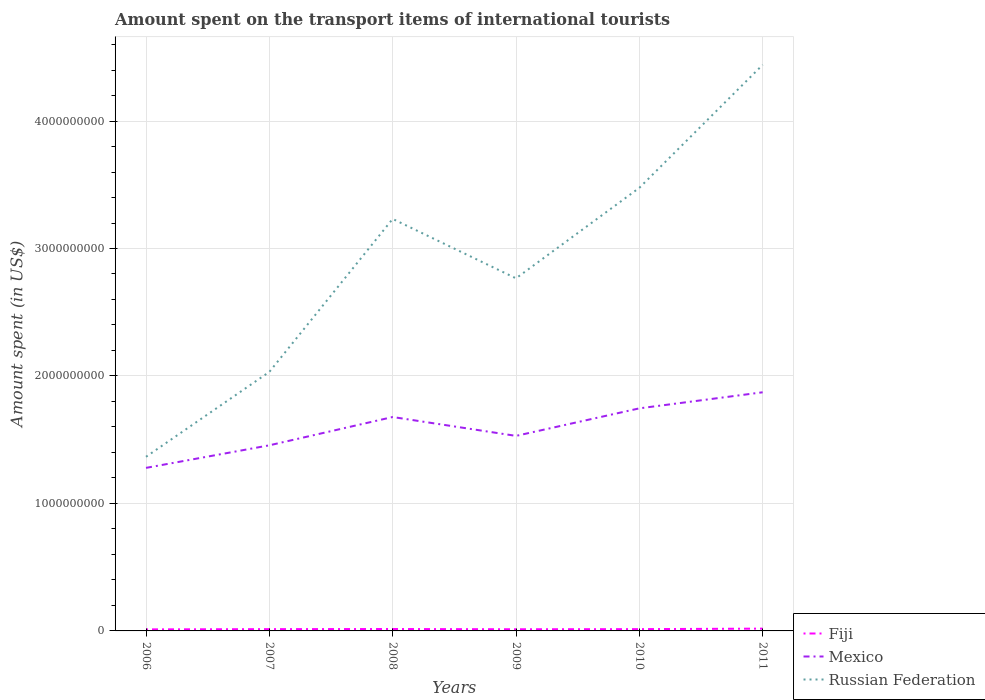How many different coloured lines are there?
Provide a short and direct response. 3. Is the number of lines equal to the number of legend labels?
Provide a short and direct response. Yes. Across all years, what is the maximum amount spent on the transport items of international tourists in Russian Federation?
Your answer should be compact. 1.37e+09. What is the total amount spent on the transport items of international tourists in Fiji in the graph?
Offer a terse response. -4.00e+06. What is the difference between the highest and the second highest amount spent on the transport items of international tourists in Russian Federation?
Provide a short and direct response. 3.08e+09. What is the difference between the highest and the lowest amount spent on the transport items of international tourists in Russian Federation?
Offer a terse response. 3. Is the amount spent on the transport items of international tourists in Mexico strictly greater than the amount spent on the transport items of international tourists in Fiji over the years?
Your answer should be very brief. No. What is the difference between two consecutive major ticks on the Y-axis?
Give a very brief answer. 1.00e+09. Does the graph contain any zero values?
Ensure brevity in your answer.  No. How many legend labels are there?
Provide a short and direct response. 3. How are the legend labels stacked?
Ensure brevity in your answer.  Vertical. What is the title of the graph?
Give a very brief answer. Amount spent on the transport items of international tourists. What is the label or title of the X-axis?
Make the answer very short. Years. What is the label or title of the Y-axis?
Your answer should be compact. Amount spent (in US$). What is the Amount spent (in US$) in Mexico in 2006?
Give a very brief answer. 1.28e+09. What is the Amount spent (in US$) in Russian Federation in 2006?
Provide a succinct answer. 1.37e+09. What is the Amount spent (in US$) in Fiji in 2007?
Your response must be concise. 1.40e+07. What is the Amount spent (in US$) of Mexico in 2007?
Give a very brief answer. 1.46e+09. What is the Amount spent (in US$) in Russian Federation in 2007?
Keep it short and to the point. 2.03e+09. What is the Amount spent (in US$) of Fiji in 2008?
Offer a terse response. 1.50e+07. What is the Amount spent (in US$) in Mexico in 2008?
Provide a short and direct response. 1.68e+09. What is the Amount spent (in US$) of Russian Federation in 2008?
Provide a succinct answer. 3.23e+09. What is the Amount spent (in US$) in Fiji in 2009?
Offer a very short reply. 1.30e+07. What is the Amount spent (in US$) of Mexico in 2009?
Provide a short and direct response. 1.53e+09. What is the Amount spent (in US$) of Russian Federation in 2009?
Keep it short and to the point. 2.77e+09. What is the Amount spent (in US$) in Fiji in 2010?
Provide a succinct answer. 1.40e+07. What is the Amount spent (in US$) in Mexico in 2010?
Offer a very short reply. 1.75e+09. What is the Amount spent (in US$) in Russian Federation in 2010?
Give a very brief answer. 3.48e+09. What is the Amount spent (in US$) of Fiji in 2011?
Make the answer very short. 1.80e+07. What is the Amount spent (in US$) in Mexico in 2011?
Ensure brevity in your answer.  1.87e+09. What is the Amount spent (in US$) of Russian Federation in 2011?
Offer a terse response. 4.44e+09. Across all years, what is the maximum Amount spent (in US$) of Fiji?
Make the answer very short. 1.80e+07. Across all years, what is the maximum Amount spent (in US$) of Mexico?
Provide a short and direct response. 1.87e+09. Across all years, what is the maximum Amount spent (in US$) of Russian Federation?
Provide a succinct answer. 4.44e+09. Across all years, what is the minimum Amount spent (in US$) of Fiji?
Your answer should be compact. 1.20e+07. Across all years, what is the minimum Amount spent (in US$) of Mexico?
Provide a succinct answer. 1.28e+09. Across all years, what is the minimum Amount spent (in US$) of Russian Federation?
Your answer should be compact. 1.37e+09. What is the total Amount spent (in US$) of Fiji in the graph?
Your answer should be very brief. 8.60e+07. What is the total Amount spent (in US$) of Mexico in the graph?
Provide a short and direct response. 9.56e+09. What is the total Amount spent (in US$) in Russian Federation in the graph?
Offer a terse response. 1.73e+1. What is the difference between the Amount spent (in US$) of Mexico in 2006 and that in 2007?
Provide a short and direct response. -1.77e+08. What is the difference between the Amount spent (in US$) of Russian Federation in 2006 and that in 2007?
Give a very brief answer. -6.66e+08. What is the difference between the Amount spent (in US$) in Fiji in 2006 and that in 2008?
Offer a very short reply. -3.00e+06. What is the difference between the Amount spent (in US$) of Mexico in 2006 and that in 2008?
Give a very brief answer. -3.99e+08. What is the difference between the Amount spent (in US$) of Russian Federation in 2006 and that in 2008?
Provide a succinct answer. -1.87e+09. What is the difference between the Amount spent (in US$) in Fiji in 2006 and that in 2009?
Give a very brief answer. -1.00e+06. What is the difference between the Amount spent (in US$) in Mexico in 2006 and that in 2009?
Your response must be concise. -2.51e+08. What is the difference between the Amount spent (in US$) of Russian Federation in 2006 and that in 2009?
Ensure brevity in your answer.  -1.40e+09. What is the difference between the Amount spent (in US$) of Mexico in 2006 and that in 2010?
Provide a succinct answer. -4.67e+08. What is the difference between the Amount spent (in US$) of Russian Federation in 2006 and that in 2010?
Make the answer very short. -2.11e+09. What is the difference between the Amount spent (in US$) in Fiji in 2006 and that in 2011?
Make the answer very short. -6.00e+06. What is the difference between the Amount spent (in US$) in Mexico in 2006 and that in 2011?
Offer a terse response. -5.93e+08. What is the difference between the Amount spent (in US$) of Russian Federation in 2006 and that in 2011?
Offer a terse response. -3.08e+09. What is the difference between the Amount spent (in US$) in Mexico in 2007 and that in 2008?
Your answer should be compact. -2.22e+08. What is the difference between the Amount spent (in US$) of Russian Federation in 2007 and that in 2008?
Keep it short and to the point. -1.20e+09. What is the difference between the Amount spent (in US$) of Fiji in 2007 and that in 2009?
Give a very brief answer. 1.00e+06. What is the difference between the Amount spent (in US$) of Mexico in 2007 and that in 2009?
Provide a short and direct response. -7.40e+07. What is the difference between the Amount spent (in US$) of Russian Federation in 2007 and that in 2009?
Provide a succinct answer. -7.34e+08. What is the difference between the Amount spent (in US$) in Mexico in 2007 and that in 2010?
Provide a succinct answer. -2.90e+08. What is the difference between the Amount spent (in US$) of Russian Federation in 2007 and that in 2010?
Your response must be concise. -1.44e+09. What is the difference between the Amount spent (in US$) of Fiji in 2007 and that in 2011?
Ensure brevity in your answer.  -4.00e+06. What is the difference between the Amount spent (in US$) of Mexico in 2007 and that in 2011?
Offer a very short reply. -4.16e+08. What is the difference between the Amount spent (in US$) in Russian Federation in 2007 and that in 2011?
Provide a short and direct response. -2.41e+09. What is the difference between the Amount spent (in US$) in Mexico in 2008 and that in 2009?
Your answer should be very brief. 1.48e+08. What is the difference between the Amount spent (in US$) in Russian Federation in 2008 and that in 2009?
Offer a very short reply. 4.66e+08. What is the difference between the Amount spent (in US$) in Mexico in 2008 and that in 2010?
Your response must be concise. -6.80e+07. What is the difference between the Amount spent (in US$) in Russian Federation in 2008 and that in 2010?
Your answer should be compact. -2.44e+08. What is the difference between the Amount spent (in US$) of Mexico in 2008 and that in 2011?
Your answer should be compact. -1.94e+08. What is the difference between the Amount spent (in US$) of Russian Federation in 2008 and that in 2011?
Your response must be concise. -1.21e+09. What is the difference between the Amount spent (in US$) of Fiji in 2009 and that in 2010?
Give a very brief answer. -1.00e+06. What is the difference between the Amount spent (in US$) of Mexico in 2009 and that in 2010?
Give a very brief answer. -2.16e+08. What is the difference between the Amount spent (in US$) in Russian Federation in 2009 and that in 2010?
Your answer should be very brief. -7.10e+08. What is the difference between the Amount spent (in US$) in Fiji in 2009 and that in 2011?
Provide a short and direct response. -5.00e+06. What is the difference between the Amount spent (in US$) in Mexico in 2009 and that in 2011?
Keep it short and to the point. -3.42e+08. What is the difference between the Amount spent (in US$) of Russian Federation in 2009 and that in 2011?
Offer a very short reply. -1.68e+09. What is the difference between the Amount spent (in US$) in Mexico in 2010 and that in 2011?
Make the answer very short. -1.26e+08. What is the difference between the Amount spent (in US$) of Russian Federation in 2010 and that in 2011?
Your response must be concise. -9.65e+08. What is the difference between the Amount spent (in US$) in Fiji in 2006 and the Amount spent (in US$) in Mexico in 2007?
Your answer should be compact. -1.44e+09. What is the difference between the Amount spent (in US$) in Fiji in 2006 and the Amount spent (in US$) in Russian Federation in 2007?
Your response must be concise. -2.02e+09. What is the difference between the Amount spent (in US$) in Mexico in 2006 and the Amount spent (in US$) in Russian Federation in 2007?
Offer a very short reply. -7.53e+08. What is the difference between the Amount spent (in US$) of Fiji in 2006 and the Amount spent (in US$) of Mexico in 2008?
Give a very brief answer. -1.67e+09. What is the difference between the Amount spent (in US$) of Fiji in 2006 and the Amount spent (in US$) of Russian Federation in 2008?
Ensure brevity in your answer.  -3.22e+09. What is the difference between the Amount spent (in US$) of Mexico in 2006 and the Amount spent (in US$) of Russian Federation in 2008?
Offer a very short reply. -1.95e+09. What is the difference between the Amount spent (in US$) in Fiji in 2006 and the Amount spent (in US$) in Mexico in 2009?
Your response must be concise. -1.52e+09. What is the difference between the Amount spent (in US$) in Fiji in 2006 and the Amount spent (in US$) in Russian Federation in 2009?
Make the answer very short. -2.75e+09. What is the difference between the Amount spent (in US$) in Mexico in 2006 and the Amount spent (in US$) in Russian Federation in 2009?
Offer a terse response. -1.49e+09. What is the difference between the Amount spent (in US$) in Fiji in 2006 and the Amount spent (in US$) in Mexico in 2010?
Offer a very short reply. -1.73e+09. What is the difference between the Amount spent (in US$) of Fiji in 2006 and the Amount spent (in US$) of Russian Federation in 2010?
Your answer should be very brief. -3.46e+09. What is the difference between the Amount spent (in US$) of Mexico in 2006 and the Amount spent (in US$) of Russian Federation in 2010?
Provide a succinct answer. -2.20e+09. What is the difference between the Amount spent (in US$) of Fiji in 2006 and the Amount spent (in US$) of Mexico in 2011?
Make the answer very short. -1.86e+09. What is the difference between the Amount spent (in US$) of Fiji in 2006 and the Amount spent (in US$) of Russian Federation in 2011?
Provide a succinct answer. -4.43e+09. What is the difference between the Amount spent (in US$) in Mexico in 2006 and the Amount spent (in US$) in Russian Federation in 2011?
Your response must be concise. -3.16e+09. What is the difference between the Amount spent (in US$) of Fiji in 2007 and the Amount spent (in US$) of Mexico in 2008?
Give a very brief answer. -1.66e+09. What is the difference between the Amount spent (in US$) in Fiji in 2007 and the Amount spent (in US$) in Russian Federation in 2008?
Make the answer very short. -3.22e+09. What is the difference between the Amount spent (in US$) in Mexico in 2007 and the Amount spent (in US$) in Russian Federation in 2008?
Keep it short and to the point. -1.78e+09. What is the difference between the Amount spent (in US$) in Fiji in 2007 and the Amount spent (in US$) in Mexico in 2009?
Your answer should be compact. -1.52e+09. What is the difference between the Amount spent (in US$) of Fiji in 2007 and the Amount spent (in US$) of Russian Federation in 2009?
Ensure brevity in your answer.  -2.75e+09. What is the difference between the Amount spent (in US$) of Mexico in 2007 and the Amount spent (in US$) of Russian Federation in 2009?
Keep it short and to the point. -1.31e+09. What is the difference between the Amount spent (in US$) of Fiji in 2007 and the Amount spent (in US$) of Mexico in 2010?
Offer a very short reply. -1.73e+09. What is the difference between the Amount spent (in US$) of Fiji in 2007 and the Amount spent (in US$) of Russian Federation in 2010?
Your response must be concise. -3.46e+09. What is the difference between the Amount spent (in US$) of Mexico in 2007 and the Amount spent (in US$) of Russian Federation in 2010?
Offer a very short reply. -2.02e+09. What is the difference between the Amount spent (in US$) in Fiji in 2007 and the Amount spent (in US$) in Mexico in 2011?
Provide a succinct answer. -1.86e+09. What is the difference between the Amount spent (in US$) of Fiji in 2007 and the Amount spent (in US$) of Russian Federation in 2011?
Make the answer very short. -4.43e+09. What is the difference between the Amount spent (in US$) in Mexico in 2007 and the Amount spent (in US$) in Russian Federation in 2011?
Your response must be concise. -2.98e+09. What is the difference between the Amount spent (in US$) in Fiji in 2008 and the Amount spent (in US$) in Mexico in 2009?
Keep it short and to the point. -1.52e+09. What is the difference between the Amount spent (in US$) of Fiji in 2008 and the Amount spent (in US$) of Russian Federation in 2009?
Give a very brief answer. -2.75e+09. What is the difference between the Amount spent (in US$) of Mexico in 2008 and the Amount spent (in US$) of Russian Federation in 2009?
Offer a terse response. -1.09e+09. What is the difference between the Amount spent (in US$) in Fiji in 2008 and the Amount spent (in US$) in Mexico in 2010?
Provide a succinct answer. -1.73e+09. What is the difference between the Amount spent (in US$) in Fiji in 2008 and the Amount spent (in US$) in Russian Federation in 2010?
Keep it short and to the point. -3.46e+09. What is the difference between the Amount spent (in US$) in Mexico in 2008 and the Amount spent (in US$) in Russian Federation in 2010?
Offer a very short reply. -1.80e+09. What is the difference between the Amount spent (in US$) in Fiji in 2008 and the Amount spent (in US$) in Mexico in 2011?
Offer a very short reply. -1.86e+09. What is the difference between the Amount spent (in US$) of Fiji in 2008 and the Amount spent (in US$) of Russian Federation in 2011?
Offer a terse response. -4.43e+09. What is the difference between the Amount spent (in US$) in Mexico in 2008 and the Amount spent (in US$) in Russian Federation in 2011?
Make the answer very short. -2.76e+09. What is the difference between the Amount spent (in US$) in Fiji in 2009 and the Amount spent (in US$) in Mexico in 2010?
Give a very brief answer. -1.73e+09. What is the difference between the Amount spent (in US$) of Fiji in 2009 and the Amount spent (in US$) of Russian Federation in 2010?
Your answer should be compact. -3.46e+09. What is the difference between the Amount spent (in US$) in Mexico in 2009 and the Amount spent (in US$) in Russian Federation in 2010?
Your response must be concise. -1.95e+09. What is the difference between the Amount spent (in US$) of Fiji in 2009 and the Amount spent (in US$) of Mexico in 2011?
Provide a short and direct response. -1.86e+09. What is the difference between the Amount spent (in US$) in Fiji in 2009 and the Amount spent (in US$) in Russian Federation in 2011?
Ensure brevity in your answer.  -4.43e+09. What is the difference between the Amount spent (in US$) of Mexico in 2009 and the Amount spent (in US$) of Russian Federation in 2011?
Provide a succinct answer. -2.91e+09. What is the difference between the Amount spent (in US$) in Fiji in 2010 and the Amount spent (in US$) in Mexico in 2011?
Offer a terse response. -1.86e+09. What is the difference between the Amount spent (in US$) in Fiji in 2010 and the Amount spent (in US$) in Russian Federation in 2011?
Give a very brief answer. -4.43e+09. What is the difference between the Amount spent (in US$) of Mexico in 2010 and the Amount spent (in US$) of Russian Federation in 2011?
Give a very brief answer. -2.70e+09. What is the average Amount spent (in US$) in Fiji per year?
Give a very brief answer. 1.43e+07. What is the average Amount spent (in US$) of Mexico per year?
Offer a terse response. 1.59e+09. What is the average Amount spent (in US$) of Russian Federation per year?
Give a very brief answer. 2.89e+09. In the year 2006, what is the difference between the Amount spent (in US$) in Fiji and Amount spent (in US$) in Mexico?
Ensure brevity in your answer.  -1.27e+09. In the year 2006, what is the difference between the Amount spent (in US$) in Fiji and Amount spent (in US$) in Russian Federation?
Your answer should be compact. -1.35e+09. In the year 2006, what is the difference between the Amount spent (in US$) in Mexico and Amount spent (in US$) in Russian Federation?
Your answer should be very brief. -8.70e+07. In the year 2007, what is the difference between the Amount spent (in US$) of Fiji and Amount spent (in US$) of Mexico?
Keep it short and to the point. -1.44e+09. In the year 2007, what is the difference between the Amount spent (in US$) in Fiji and Amount spent (in US$) in Russian Federation?
Your answer should be very brief. -2.02e+09. In the year 2007, what is the difference between the Amount spent (in US$) of Mexico and Amount spent (in US$) of Russian Federation?
Provide a short and direct response. -5.76e+08. In the year 2008, what is the difference between the Amount spent (in US$) of Fiji and Amount spent (in US$) of Mexico?
Make the answer very short. -1.66e+09. In the year 2008, what is the difference between the Amount spent (in US$) of Fiji and Amount spent (in US$) of Russian Federation?
Offer a terse response. -3.22e+09. In the year 2008, what is the difference between the Amount spent (in US$) of Mexico and Amount spent (in US$) of Russian Federation?
Offer a terse response. -1.55e+09. In the year 2009, what is the difference between the Amount spent (in US$) in Fiji and Amount spent (in US$) in Mexico?
Your response must be concise. -1.52e+09. In the year 2009, what is the difference between the Amount spent (in US$) in Fiji and Amount spent (in US$) in Russian Federation?
Ensure brevity in your answer.  -2.75e+09. In the year 2009, what is the difference between the Amount spent (in US$) of Mexico and Amount spent (in US$) of Russian Federation?
Offer a very short reply. -1.24e+09. In the year 2010, what is the difference between the Amount spent (in US$) in Fiji and Amount spent (in US$) in Mexico?
Your response must be concise. -1.73e+09. In the year 2010, what is the difference between the Amount spent (in US$) of Fiji and Amount spent (in US$) of Russian Federation?
Offer a very short reply. -3.46e+09. In the year 2010, what is the difference between the Amount spent (in US$) in Mexico and Amount spent (in US$) in Russian Federation?
Provide a short and direct response. -1.73e+09. In the year 2011, what is the difference between the Amount spent (in US$) of Fiji and Amount spent (in US$) of Mexico?
Offer a terse response. -1.85e+09. In the year 2011, what is the difference between the Amount spent (in US$) of Fiji and Amount spent (in US$) of Russian Federation?
Your response must be concise. -4.42e+09. In the year 2011, what is the difference between the Amount spent (in US$) of Mexico and Amount spent (in US$) of Russian Federation?
Your response must be concise. -2.57e+09. What is the ratio of the Amount spent (in US$) of Mexico in 2006 to that in 2007?
Provide a short and direct response. 0.88. What is the ratio of the Amount spent (in US$) in Russian Federation in 2006 to that in 2007?
Ensure brevity in your answer.  0.67. What is the ratio of the Amount spent (in US$) in Fiji in 2006 to that in 2008?
Ensure brevity in your answer.  0.8. What is the ratio of the Amount spent (in US$) in Mexico in 2006 to that in 2008?
Offer a very short reply. 0.76. What is the ratio of the Amount spent (in US$) in Russian Federation in 2006 to that in 2008?
Your answer should be very brief. 0.42. What is the ratio of the Amount spent (in US$) in Mexico in 2006 to that in 2009?
Your response must be concise. 0.84. What is the ratio of the Amount spent (in US$) of Russian Federation in 2006 to that in 2009?
Make the answer very short. 0.49. What is the ratio of the Amount spent (in US$) of Mexico in 2006 to that in 2010?
Make the answer very short. 0.73. What is the ratio of the Amount spent (in US$) in Russian Federation in 2006 to that in 2010?
Provide a succinct answer. 0.39. What is the ratio of the Amount spent (in US$) of Fiji in 2006 to that in 2011?
Keep it short and to the point. 0.67. What is the ratio of the Amount spent (in US$) in Mexico in 2006 to that in 2011?
Offer a terse response. 0.68. What is the ratio of the Amount spent (in US$) of Russian Federation in 2006 to that in 2011?
Give a very brief answer. 0.31. What is the ratio of the Amount spent (in US$) of Fiji in 2007 to that in 2008?
Keep it short and to the point. 0.93. What is the ratio of the Amount spent (in US$) of Mexico in 2007 to that in 2008?
Your answer should be compact. 0.87. What is the ratio of the Amount spent (in US$) in Russian Federation in 2007 to that in 2008?
Keep it short and to the point. 0.63. What is the ratio of the Amount spent (in US$) of Fiji in 2007 to that in 2009?
Provide a succinct answer. 1.08. What is the ratio of the Amount spent (in US$) in Mexico in 2007 to that in 2009?
Provide a succinct answer. 0.95. What is the ratio of the Amount spent (in US$) in Russian Federation in 2007 to that in 2009?
Your answer should be compact. 0.73. What is the ratio of the Amount spent (in US$) of Mexico in 2007 to that in 2010?
Ensure brevity in your answer.  0.83. What is the ratio of the Amount spent (in US$) of Russian Federation in 2007 to that in 2010?
Provide a succinct answer. 0.58. What is the ratio of the Amount spent (in US$) in Fiji in 2007 to that in 2011?
Ensure brevity in your answer.  0.78. What is the ratio of the Amount spent (in US$) of Mexico in 2007 to that in 2011?
Ensure brevity in your answer.  0.78. What is the ratio of the Amount spent (in US$) of Russian Federation in 2007 to that in 2011?
Your answer should be very brief. 0.46. What is the ratio of the Amount spent (in US$) in Fiji in 2008 to that in 2009?
Provide a succinct answer. 1.15. What is the ratio of the Amount spent (in US$) of Mexico in 2008 to that in 2009?
Offer a very short reply. 1.1. What is the ratio of the Amount spent (in US$) of Russian Federation in 2008 to that in 2009?
Offer a terse response. 1.17. What is the ratio of the Amount spent (in US$) of Fiji in 2008 to that in 2010?
Your answer should be very brief. 1.07. What is the ratio of the Amount spent (in US$) in Mexico in 2008 to that in 2010?
Offer a terse response. 0.96. What is the ratio of the Amount spent (in US$) of Russian Federation in 2008 to that in 2010?
Your answer should be very brief. 0.93. What is the ratio of the Amount spent (in US$) in Mexico in 2008 to that in 2011?
Offer a very short reply. 0.9. What is the ratio of the Amount spent (in US$) of Russian Federation in 2008 to that in 2011?
Ensure brevity in your answer.  0.73. What is the ratio of the Amount spent (in US$) of Fiji in 2009 to that in 2010?
Offer a terse response. 0.93. What is the ratio of the Amount spent (in US$) of Mexico in 2009 to that in 2010?
Provide a succinct answer. 0.88. What is the ratio of the Amount spent (in US$) of Russian Federation in 2009 to that in 2010?
Provide a short and direct response. 0.8. What is the ratio of the Amount spent (in US$) of Fiji in 2009 to that in 2011?
Your answer should be very brief. 0.72. What is the ratio of the Amount spent (in US$) in Mexico in 2009 to that in 2011?
Your answer should be compact. 0.82. What is the ratio of the Amount spent (in US$) in Russian Federation in 2009 to that in 2011?
Your answer should be compact. 0.62. What is the ratio of the Amount spent (in US$) of Fiji in 2010 to that in 2011?
Keep it short and to the point. 0.78. What is the ratio of the Amount spent (in US$) of Mexico in 2010 to that in 2011?
Make the answer very short. 0.93. What is the ratio of the Amount spent (in US$) of Russian Federation in 2010 to that in 2011?
Provide a short and direct response. 0.78. What is the difference between the highest and the second highest Amount spent (in US$) of Mexico?
Offer a very short reply. 1.26e+08. What is the difference between the highest and the second highest Amount spent (in US$) in Russian Federation?
Your answer should be very brief. 9.65e+08. What is the difference between the highest and the lowest Amount spent (in US$) in Fiji?
Keep it short and to the point. 6.00e+06. What is the difference between the highest and the lowest Amount spent (in US$) of Mexico?
Your response must be concise. 5.93e+08. What is the difference between the highest and the lowest Amount spent (in US$) in Russian Federation?
Your answer should be very brief. 3.08e+09. 